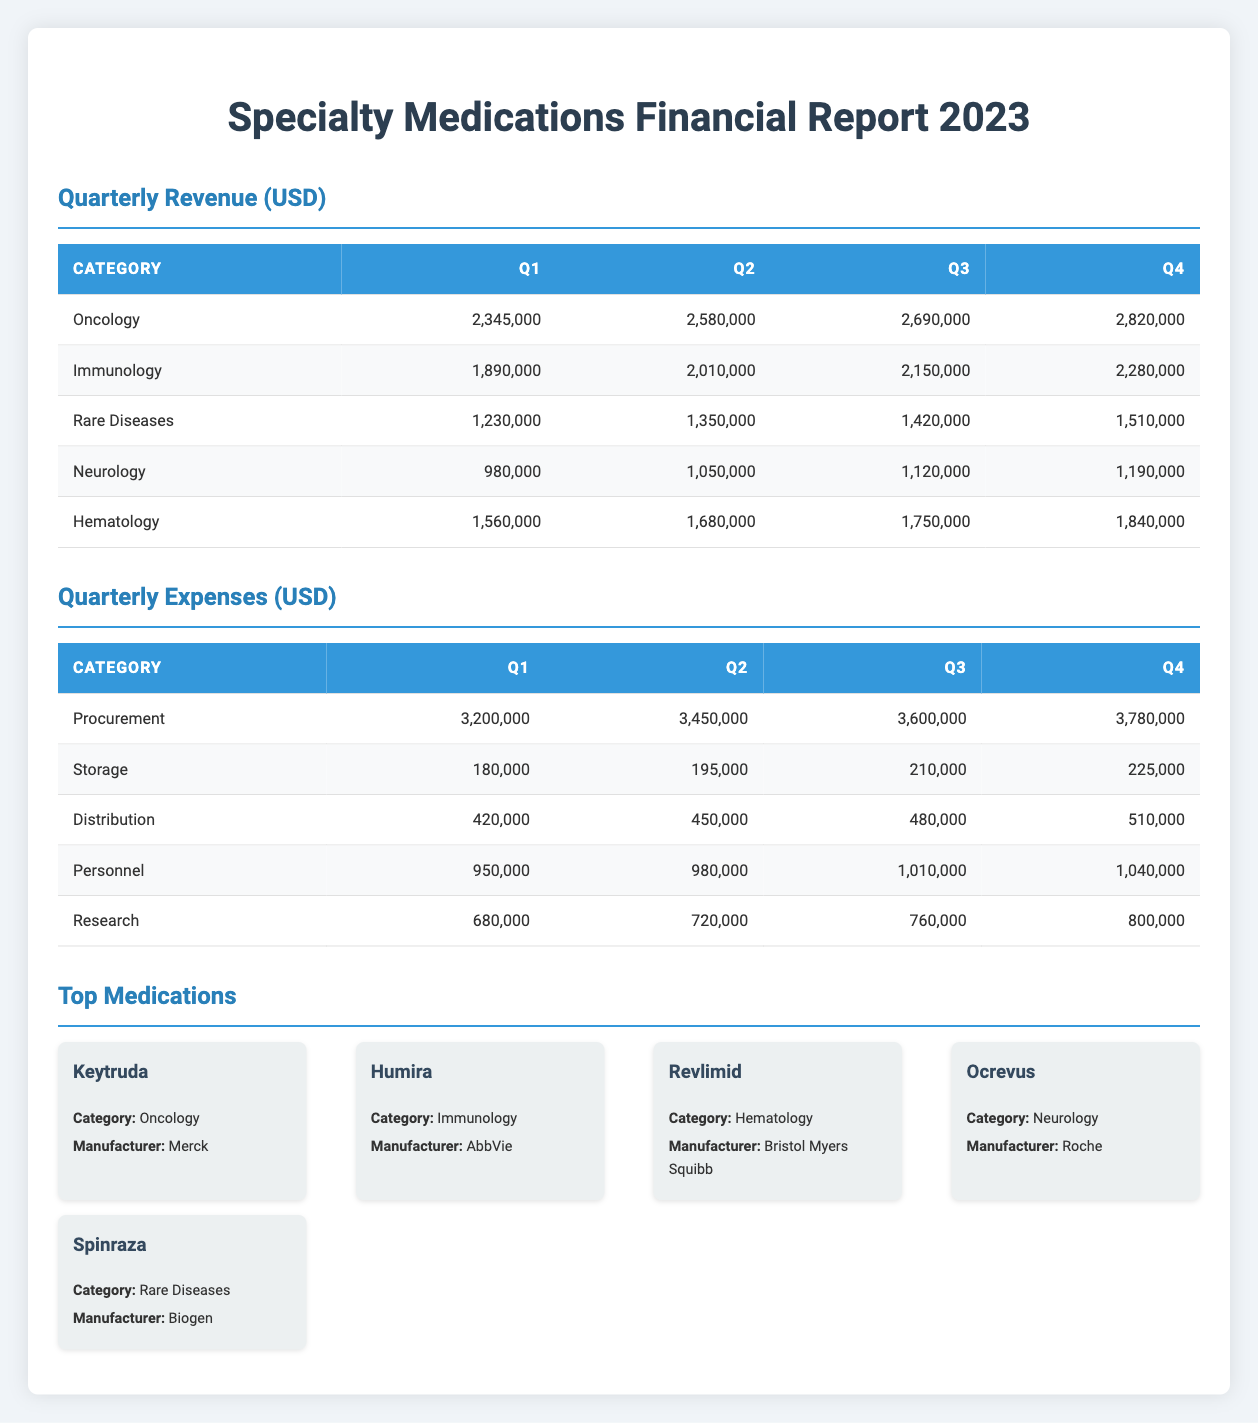What was the total revenue from oncology in Q3? To find the total revenue from oncology in Q3, we refer to the revenue section for Q3. The value for oncology in Q3 is 2,690,000.
Answer: 2,690,000 What is the percentage increase in revenue from rare diseases from Q1 to Q4? To compute the percentage increase, we first find the revenue for rare diseases in Q1 (1,230,000) and in Q4 (1,510,000). The difference is 1,510,000 - 1,230,000 = 280,000. Then, we divide the difference by the Q1 value: 280,000 / 1,230,000 ≈ 0.227. Converting this to a percentage gives us approximately 22.7%.
Answer: 22.7% Did the expenses for personnel increase every quarter? We need to look at the expenses for personnel in each quarter: Q1: 950,000, Q2: 980,000, Q3: 1,010,000, Q4: 1,040,000. Since each quarter shows an increase compared to the previous one, we can confirm that expenses for personnel increased.
Answer: Yes What was the total expenses for Q2? To find the total expenses for Q2, we sum the individual expenses: Procurement (3,450,000) + Storage (195,000) + Distribution (450,000) + Personnel (980,000) + Research (720,000). This totals to 3,450,000 + 195,000 + 450,000 + 980,000 + 720,000 = 5,795,000.
Answer: 5,795,000 Which category had the lowest expenses in Q4? In the table for Q4 expenses, we can see: Procurement (3,780,000), Storage (225,000), Distribution (510,000), Personnel (1,040,000), Research (800,000). The lowest value is for Storage, which is 225,000.
Answer: Storage What is the average revenue for immunology across all quarters? The revenue for immunology is: Q1: 1,890,000, Q2: 2,010,000, Q3: 2,150,000, Q4: 2,280,000. We sum these values: 1,890,000 + 2,010,000 + 2,150,000 + 2,280,000 = 8,330,000. To find the average, we divide by the number of quarters (4): 8,330,000 / 4 = 2,082,500.
Answer: 2,082,500 Was the total revenue for hematology in Q1 greater than the total expenses for storage in Q3? The revenue for hematology in Q1 is 1,560,000. The expenses for storage in Q3 are 210,000. Since 1,560,000 is greater than 210,000, we conclude that the total revenue for hematology is indeed greater.
Answer: Yes What was the overall change in total revenue from Q1 to Q4? We need to add the revenue for each quarter: Q1: 2,345,000 + Q2: 2,580,000 + Q3: 2,690,000 + Q4: 2,820,000 = 10,435,000 for Q1 and 2,820,000 for Q4. The change from Q1 to Q4 is 2,820,000 - 2,345,000 = 475,000.
Answer: 475,000 